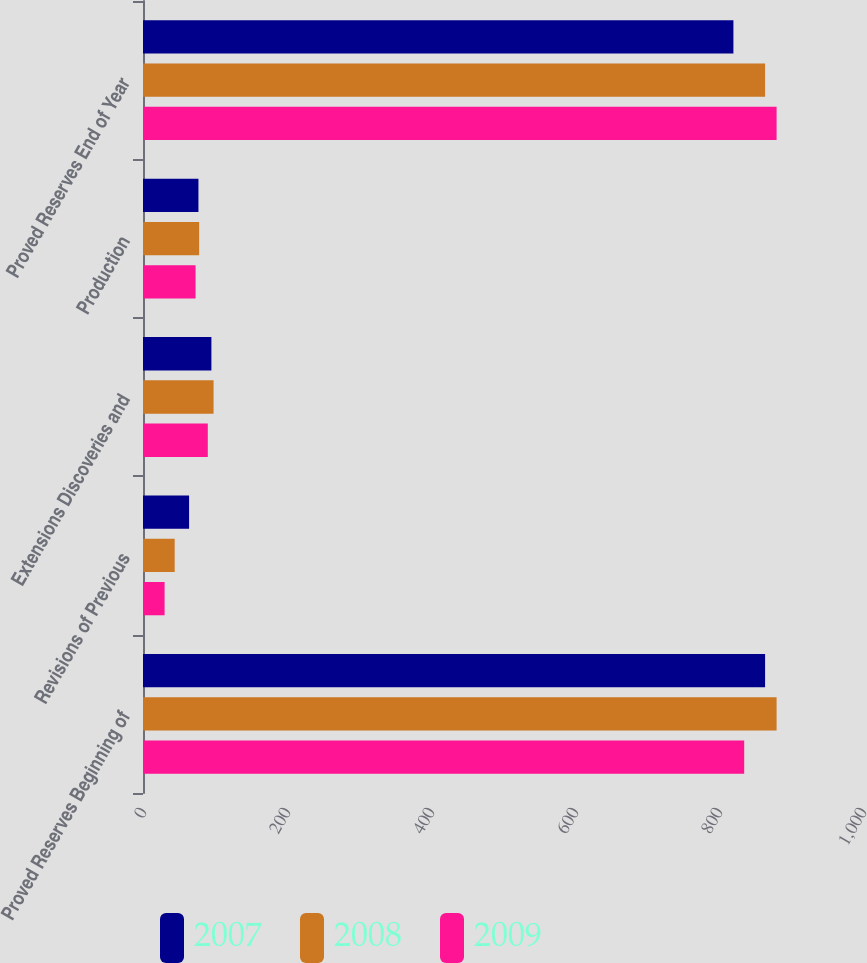Convert chart. <chart><loc_0><loc_0><loc_500><loc_500><stacked_bar_chart><ecel><fcel>Proved Reserves Beginning of<fcel>Revisions of Previous<fcel>Extensions Discoveries and<fcel>Production<fcel>Proved Reserves End of Year<nl><fcel>2007<fcel>864<fcel>64<fcel>95<fcel>77<fcel>820<nl><fcel>2008<fcel>880<fcel>44<fcel>98<fcel>78<fcel>864<nl><fcel>2009<fcel>835<fcel>30<fcel>90<fcel>73<fcel>880<nl></chart> 